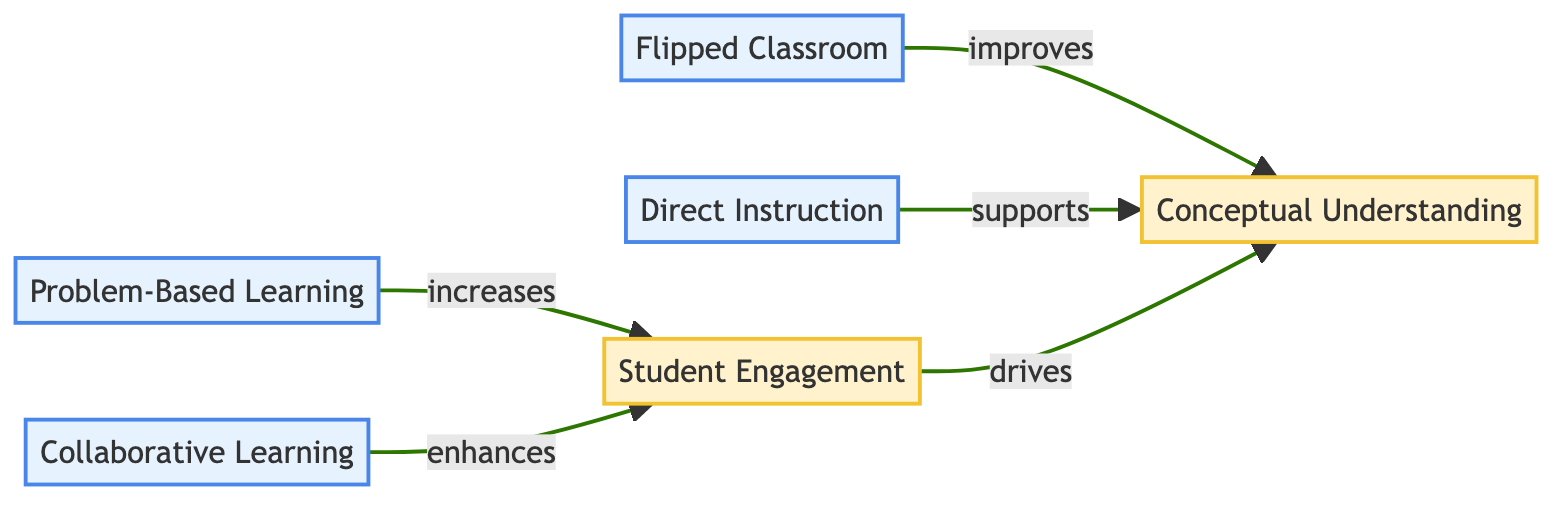What is the relationship between Problem-Based Learning and Student Engagement? The diagram shows that Problem-Based Learning increases Student Engagement, indicating a direct positive impact from the teaching methodology to student involvement in math learning.
Answer: increases How many teaching methodologies are represented in the diagram? The diagram contains four distinct teaching methodologies: Problem-Based Learning, Collaborative Learning, Flipped Classroom, and Direct Instruction, thus totaling four methodologies.
Answer: 4 Which teaching methodology improves Conceptual Understanding? The diagram states that the Flipped Classroom improves Conceptual Understanding, highlighting its role in enhancing deeper comprehension of math concepts beyond rote memorization.
Answer: improves What connects Student Engagement to Conceptual Understanding? The diagram indicates that Student Engagement drives Conceptual Understanding, establishing a link where increased student participation leads to better understanding of mathematical concepts.
Answer: drives Which teaching methodology enhances Student Engagement? According to the diagram, Collaborative Learning enhances Student Engagement, showing that collaborative approaches foster greater student interest and participation in math learning.
Answer: enhances What is the role of Direct Instruction regarding Conceptual Understanding? The diagram illustrates that Direct Instruction supports Conceptual Understanding, suggesting that this traditional methodology provides a helpful foundation for grasping mathematical concepts clearly.
Answer: supports Is there a direct link between Collaborative Learning and Conceptual Understanding? An examination of the diagram reveals that there is no direct link indicated between Collaborative Learning and Conceptual Understanding; instead, Collaborative Learning connects only to Student Engagement.
Answer: No What is the total number of edges in the diagram? The diagram features five directed edges, each representing the relationships between teaching methodologies and their impact on student outcomes, leading from one method to either Student Engagement or Conceptual Understanding.
Answer: 5 